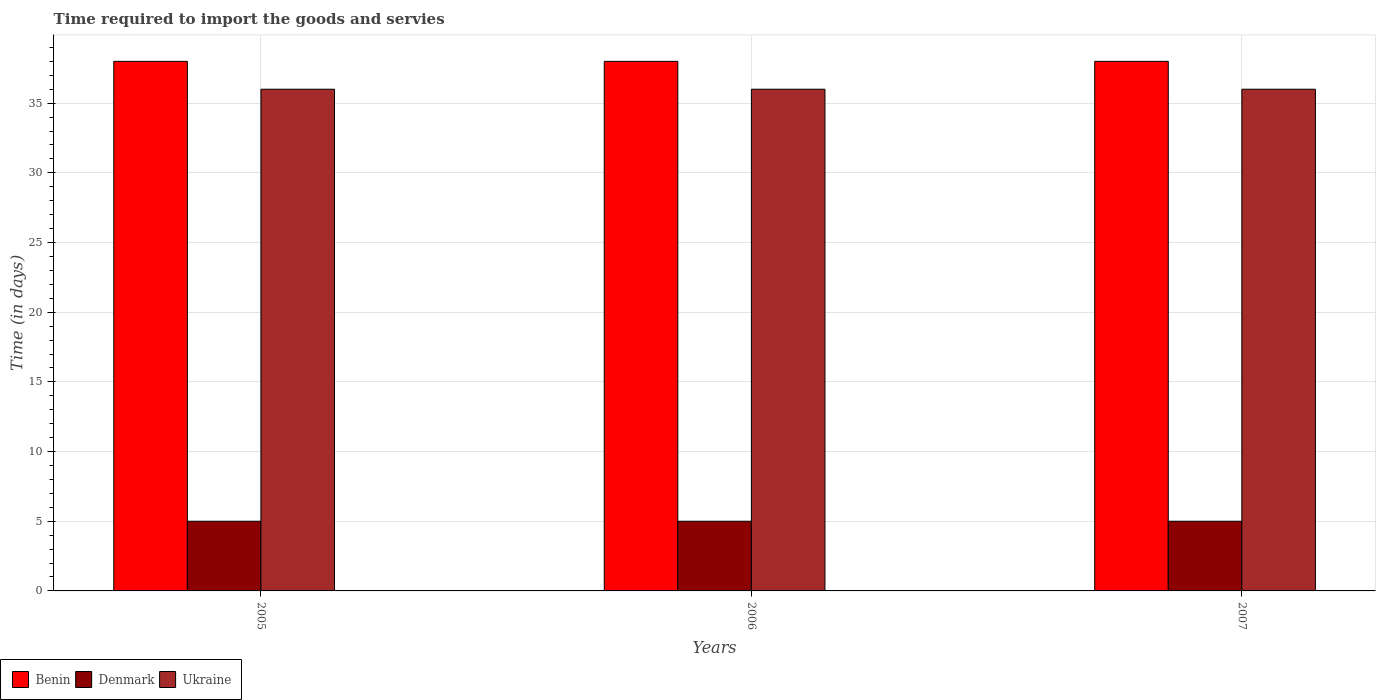How many different coloured bars are there?
Ensure brevity in your answer.  3. How many groups of bars are there?
Provide a succinct answer. 3. How many bars are there on the 3rd tick from the right?
Give a very brief answer. 3. What is the label of the 2nd group of bars from the left?
Ensure brevity in your answer.  2006. In how many cases, is the number of bars for a given year not equal to the number of legend labels?
Give a very brief answer. 0. What is the number of days required to import the goods and services in Benin in 2005?
Keep it short and to the point. 38. Across all years, what is the maximum number of days required to import the goods and services in Ukraine?
Your response must be concise. 36. Across all years, what is the minimum number of days required to import the goods and services in Denmark?
Provide a succinct answer. 5. In which year was the number of days required to import the goods and services in Denmark maximum?
Your answer should be very brief. 2005. In which year was the number of days required to import the goods and services in Denmark minimum?
Offer a very short reply. 2005. What is the total number of days required to import the goods and services in Denmark in the graph?
Keep it short and to the point. 15. What is the difference between the number of days required to import the goods and services in Ukraine in 2005 and that in 2007?
Your answer should be very brief. 0. What is the difference between the number of days required to import the goods and services in Denmark in 2007 and the number of days required to import the goods and services in Benin in 2005?
Provide a short and direct response. -33. What is the average number of days required to import the goods and services in Benin per year?
Your answer should be very brief. 38. In the year 2006, what is the difference between the number of days required to import the goods and services in Ukraine and number of days required to import the goods and services in Denmark?
Give a very brief answer. 31. What does the 1st bar from the left in 2005 represents?
Keep it short and to the point. Benin. What does the 2nd bar from the right in 2006 represents?
Offer a very short reply. Denmark. How many bars are there?
Ensure brevity in your answer.  9. Are all the bars in the graph horizontal?
Ensure brevity in your answer.  No. How many years are there in the graph?
Offer a very short reply. 3. What is the difference between two consecutive major ticks on the Y-axis?
Your answer should be compact. 5. Does the graph contain any zero values?
Your answer should be very brief. No. How are the legend labels stacked?
Keep it short and to the point. Horizontal. What is the title of the graph?
Keep it short and to the point. Time required to import the goods and servies. Does "Heavily indebted poor countries" appear as one of the legend labels in the graph?
Keep it short and to the point. No. What is the label or title of the X-axis?
Make the answer very short. Years. What is the label or title of the Y-axis?
Ensure brevity in your answer.  Time (in days). What is the Time (in days) of Benin in 2005?
Offer a terse response. 38. What is the Time (in days) of Denmark in 2005?
Give a very brief answer. 5. What is the Time (in days) of Denmark in 2006?
Give a very brief answer. 5. What is the Time (in days) of Denmark in 2007?
Your response must be concise. 5. Across all years, what is the maximum Time (in days) in Denmark?
Your answer should be compact. 5. Across all years, what is the maximum Time (in days) in Ukraine?
Your answer should be compact. 36. What is the total Time (in days) of Benin in the graph?
Provide a short and direct response. 114. What is the total Time (in days) in Denmark in the graph?
Provide a short and direct response. 15. What is the total Time (in days) in Ukraine in the graph?
Offer a very short reply. 108. What is the difference between the Time (in days) in Benin in 2005 and that in 2006?
Ensure brevity in your answer.  0. What is the difference between the Time (in days) in Denmark in 2005 and that in 2006?
Give a very brief answer. 0. What is the difference between the Time (in days) of Ukraine in 2005 and that in 2006?
Make the answer very short. 0. What is the difference between the Time (in days) of Ukraine in 2005 and that in 2007?
Ensure brevity in your answer.  0. What is the difference between the Time (in days) in Denmark in 2006 and that in 2007?
Your answer should be compact. 0. What is the difference between the Time (in days) in Ukraine in 2006 and that in 2007?
Give a very brief answer. 0. What is the difference between the Time (in days) of Denmark in 2005 and the Time (in days) of Ukraine in 2006?
Ensure brevity in your answer.  -31. What is the difference between the Time (in days) in Denmark in 2005 and the Time (in days) in Ukraine in 2007?
Your answer should be very brief. -31. What is the difference between the Time (in days) in Benin in 2006 and the Time (in days) in Denmark in 2007?
Give a very brief answer. 33. What is the difference between the Time (in days) in Denmark in 2006 and the Time (in days) in Ukraine in 2007?
Ensure brevity in your answer.  -31. What is the average Time (in days) of Benin per year?
Ensure brevity in your answer.  38. In the year 2005, what is the difference between the Time (in days) of Benin and Time (in days) of Denmark?
Offer a very short reply. 33. In the year 2005, what is the difference between the Time (in days) in Denmark and Time (in days) in Ukraine?
Make the answer very short. -31. In the year 2006, what is the difference between the Time (in days) of Denmark and Time (in days) of Ukraine?
Provide a short and direct response. -31. In the year 2007, what is the difference between the Time (in days) of Benin and Time (in days) of Denmark?
Keep it short and to the point. 33. In the year 2007, what is the difference between the Time (in days) of Denmark and Time (in days) of Ukraine?
Your answer should be very brief. -31. What is the ratio of the Time (in days) of Benin in 2005 to that in 2006?
Your response must be concise. 1. What is the ratio of the Time (in days) of Denmark in 2005 to that in 2006?
Provide a succinct answer. 1. What is the ratio of the Time (in days) of Ukraine in 2005 to that in 2006?
Keep it short and to the point. 1. What is the ratio of the Time (in days) of Benin in 2005 to that in 2007?
Your answer should be compact. 1. What is the ratio of the Time (in days) of Ukraine in 2005 to that in 2007?
Your answer should be compact. 1. What is the ratio of the Time (in days) of Denmark in 2006 to that in 2007?
Offer a terse response. 1. What is the ratio of the Time (in days) of Ukraine in 2006 to that in 2007?
Provide a short and direct response. 1. What is the difference between the highest and the second highest Time (in days) of Benin?
Offer a very short reply. 0. What is the difference between the highest and the lowest Time (in days) in Benin?
Your answer should be very brief. 0. What is the difference between the highest and the lowest Time (in days) in Ukraine?
Give a very brief answer. 0. 